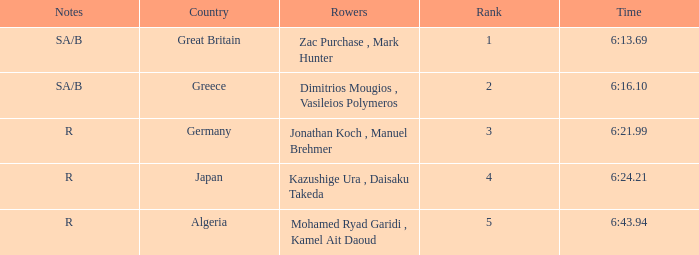What country is ranked #2? Greece. 